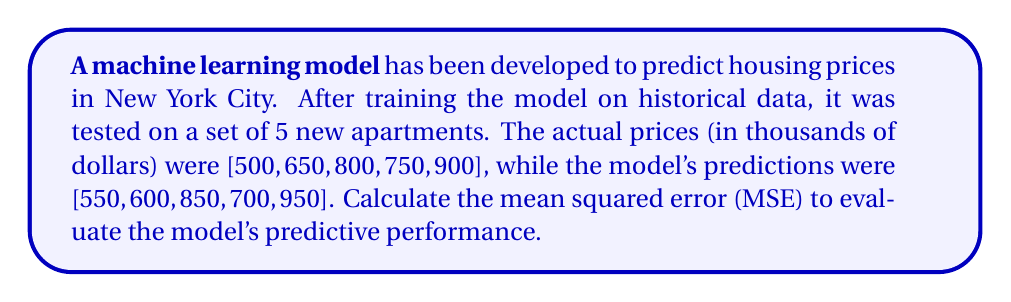Solve this math problem. To calculate the mean squared error (MSE), we need to follow these steps:

1. Calculate the difference between each predicted value and the actual value.
2. Square each of these differences.
3. Calculate the average of these squared differences.

Let's go through this process step-by-step:

1. Calculate the differences:
   $550 - 500 = 50$
   $600 - 650 = -50$
   $850 - 800 = 50$
   $700 - 750 = -50$
   $950 - 900 = 50$

2. Square each difference:
   $50^2 = 2500$
   $(-50)^2 = 2500$
   $50^2 = 2500$
   $(-50)^2 = 2500$
   $50^2 = 2500$

3. Calculate the average of the squared differences:

   $$MSE = \frac{1}{n}\sum_{i=1}^n (y_i - \hat{y}_i)^2$$

   Where $n$ is the number of observations, $y_i$ are the actual values, and $\hat{y}_i$ are the predicted values.

   $$MSE = \frac{2500 + 2500 + 2500 + 2500 + 2500}{5}$$

   $$MSE = \frac{12500}{5} = 2500$$

Therefore, the mean squared error for this model's predictions is 2500.
Answer: 2500 